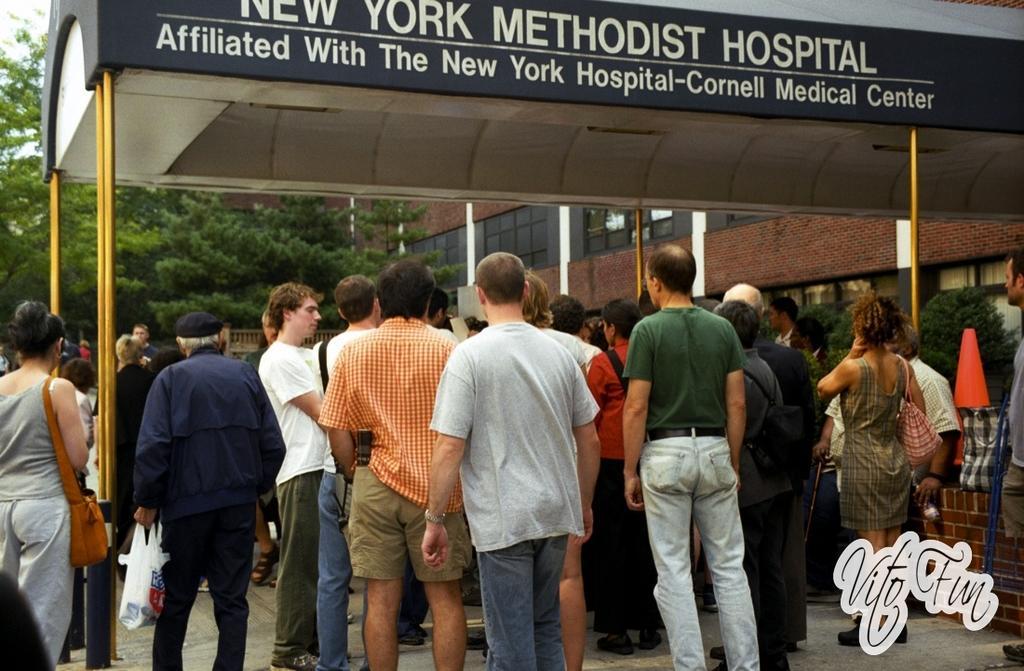In one or two sentences, can you explain what this image depicts? In this image, we can see under the shelter. There is a divider cone on the right side of the image. There are some trees in front of the building. 